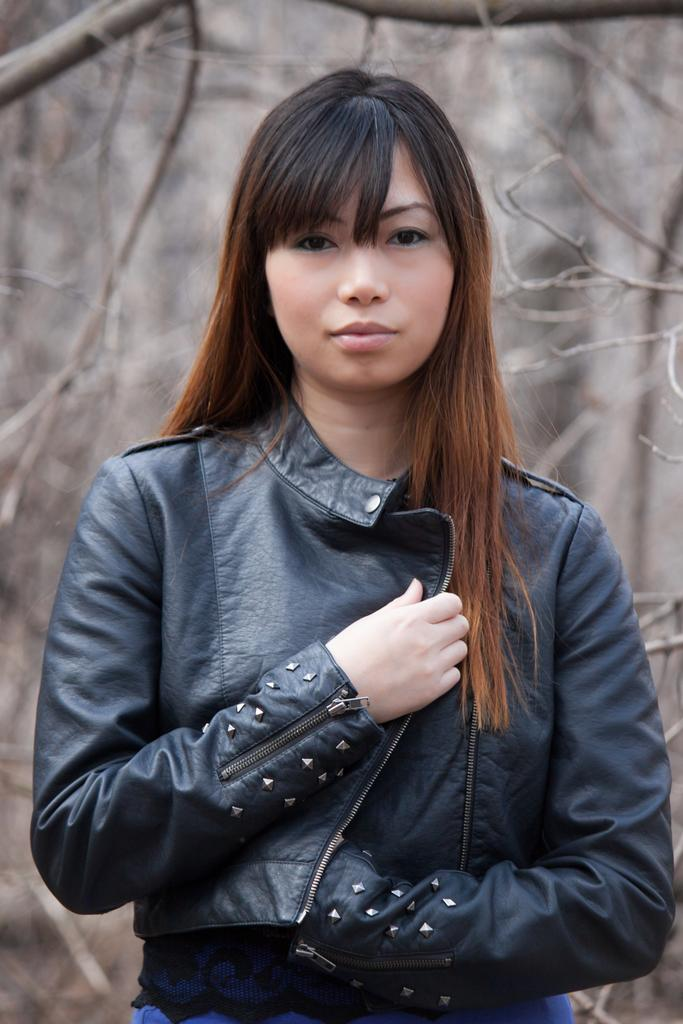Who is the main subject in the image? There is a beautiful woman in the image. Where is the woman located in the image? The woman is in the middle of the image. What is the woman wearing in the image? The woman is wearing a black coat in the image. What can be seen behind the woman in the image? There are dried sticks behind the woman in the image. What type of tax is being discussed in the image? There is no mention of tax or any discussion in the image; it features a beautiful woman wearing a black coat with dried sticks behind her. 